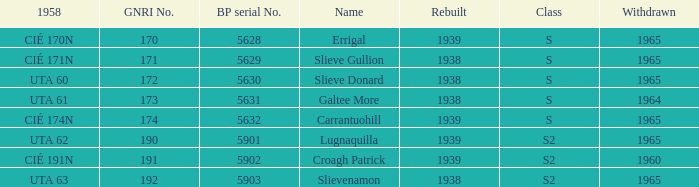What is the smallest withdrawn value with a GNRI greater than 172, name of Croagh Patrick and was rebuilt before 1939? None. 